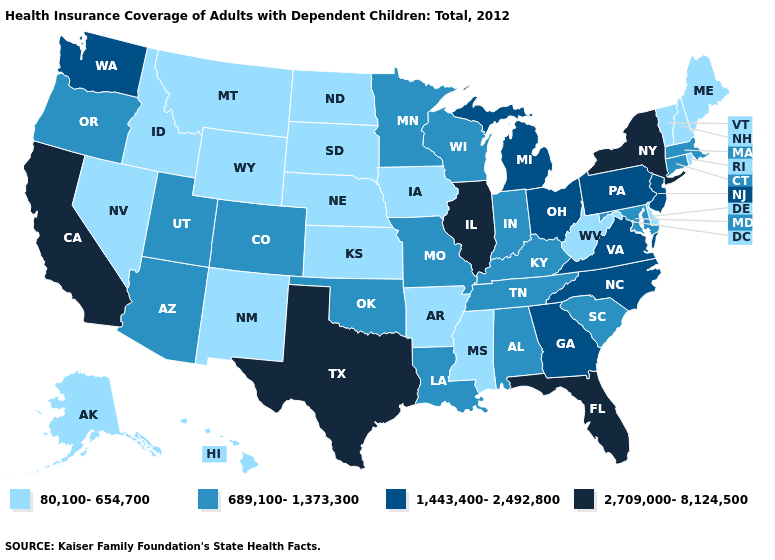Name the states that have a value in the range 689,100-1,373,300?
Be succinct. Alabama, Arizona, Colorado, Connecticut, Indiana, Kentucky, Louisiana, Maryland, Massachusetts, Minnesota, Missouri, Oklahoma, Oregon, South Carolina, Tennessee, Utah, Wisconsin. Does Florida have the highest value in the USA?
Write a very short answer. Yes. Among the states that border Iowa , does Missouri have the lowest value?
Concise answer only. No. Which states hav the highest value in the West?
Write a very short answer. California. Among the states that border Montana , which have the highest value?
Short answer required. Idaho, North Dakota, South Dakota, Wyoming. Among the states that border Montana , which have the highest value?
Concise answer only. Idaho, North Dakota, South Dakota, Wyoming. What is the highest value in the USA?
Answer briefly. 2,709,000-8,124,500. What is the lowest value in the South?
Concise answer only. 80,100-654,700. What is the value of Colorado?
Short answer required. 689,100-1,373,300. Does South Carolina have the same value as Delaware?
Give a very brief answer. No. What is the value of Ohio?
Concise answer only. 1,443,400-2,492,800. Does Iowa have the same value as New Mexico?
Keep it brief. Yes. Among the states that border Pennsylvania , which have the lowest value?
Short answer required. Delaware, West Virginia. Among the states that border South Carolina , which have the highest value?
Write a very short answer. Georgia, North Carolina. 